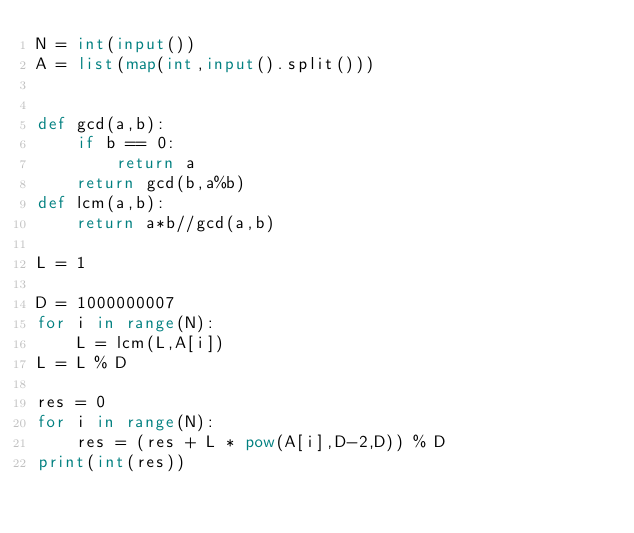Convert code to text. <code><loc_0><loc_0><loc_500><loc_500><_Python_>N = int(input())
A = list(map(int,input().split()))


def gcd(a,b):
    if b == 0:
        return a
    return gcd(b,a%b)
def lcm(a,b):
    return a*b//gcd(a,b)

L = 1

D = 1000000007
for i in range(N):
    L = lcm(L,A[i]) 
L = L % D

res = 0
for i in range(N):
    res = (res + L * pow(A[i],D-2,D)) % D  
print(int(res))



</code> 